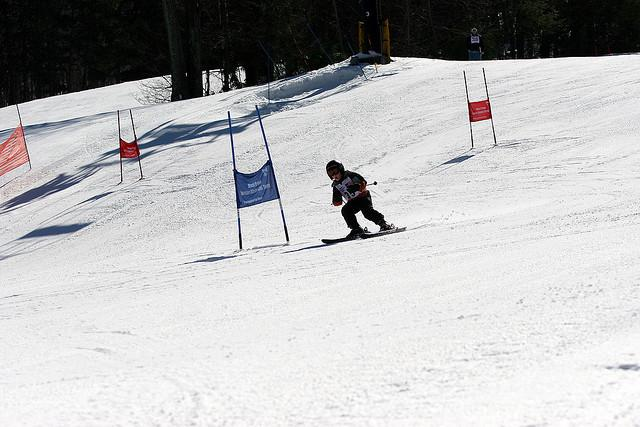What is the boy doing? Please explain your reasoning. descending. The skier started at the top of the hill with their knees bent for speed and are heading downwards on the hill. 